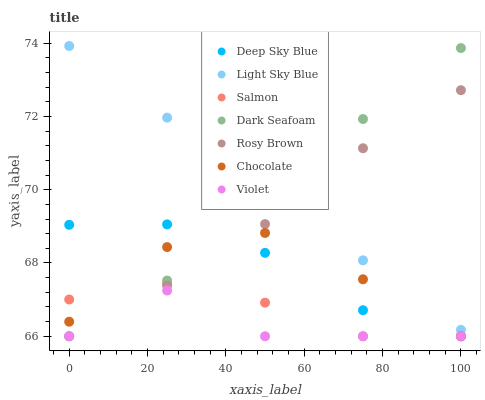Does Violet have the minimum area under the curve?
Answer yes or no. Yes. Does Light Sky Blue have the maximum area under the curve?
Answer yes or no. Yes. Does Salmon have the minimum area under the curve?
Answer yes or no. No. Does Salmon have the maximum area under the curve?
Answer yes or no. No. Is Dark Seafoam the smoothest?
Answer yes or no. Yes. Is Violet the roughest?
Answer yes or no. Yes. Is Salmon the smoothest?
Answer yes or no. No. Is Salmon the roughest?
Answer yes or no. No. Does Rosy Brown have the lowest value?
Answer yes or no. Yes. Does Light Sky Blue have the lowest value?
Answer yes or no. No. Does Light Sky Blue have the highest value?
Answer yes or no. Yes. Does Salmon have the highest value?
Answer yes or no. No. Is Deep Sky Blue less than Light Sky Blue?
Answer yes or no. Yes. Is Light Sky Blue greater than Salmon?
Answer yes or no. Yes. Does Chocolate intersect Salmon?
Answer yes or no. Yes. Is Chocolate less than Salmon?
Answer yes or no. No. Is Chocolate greater than Salmon?
Answer yes or no. No. Does Deep Sky Blue intersect Light Sky Blue?
Answer yes or no. No. 